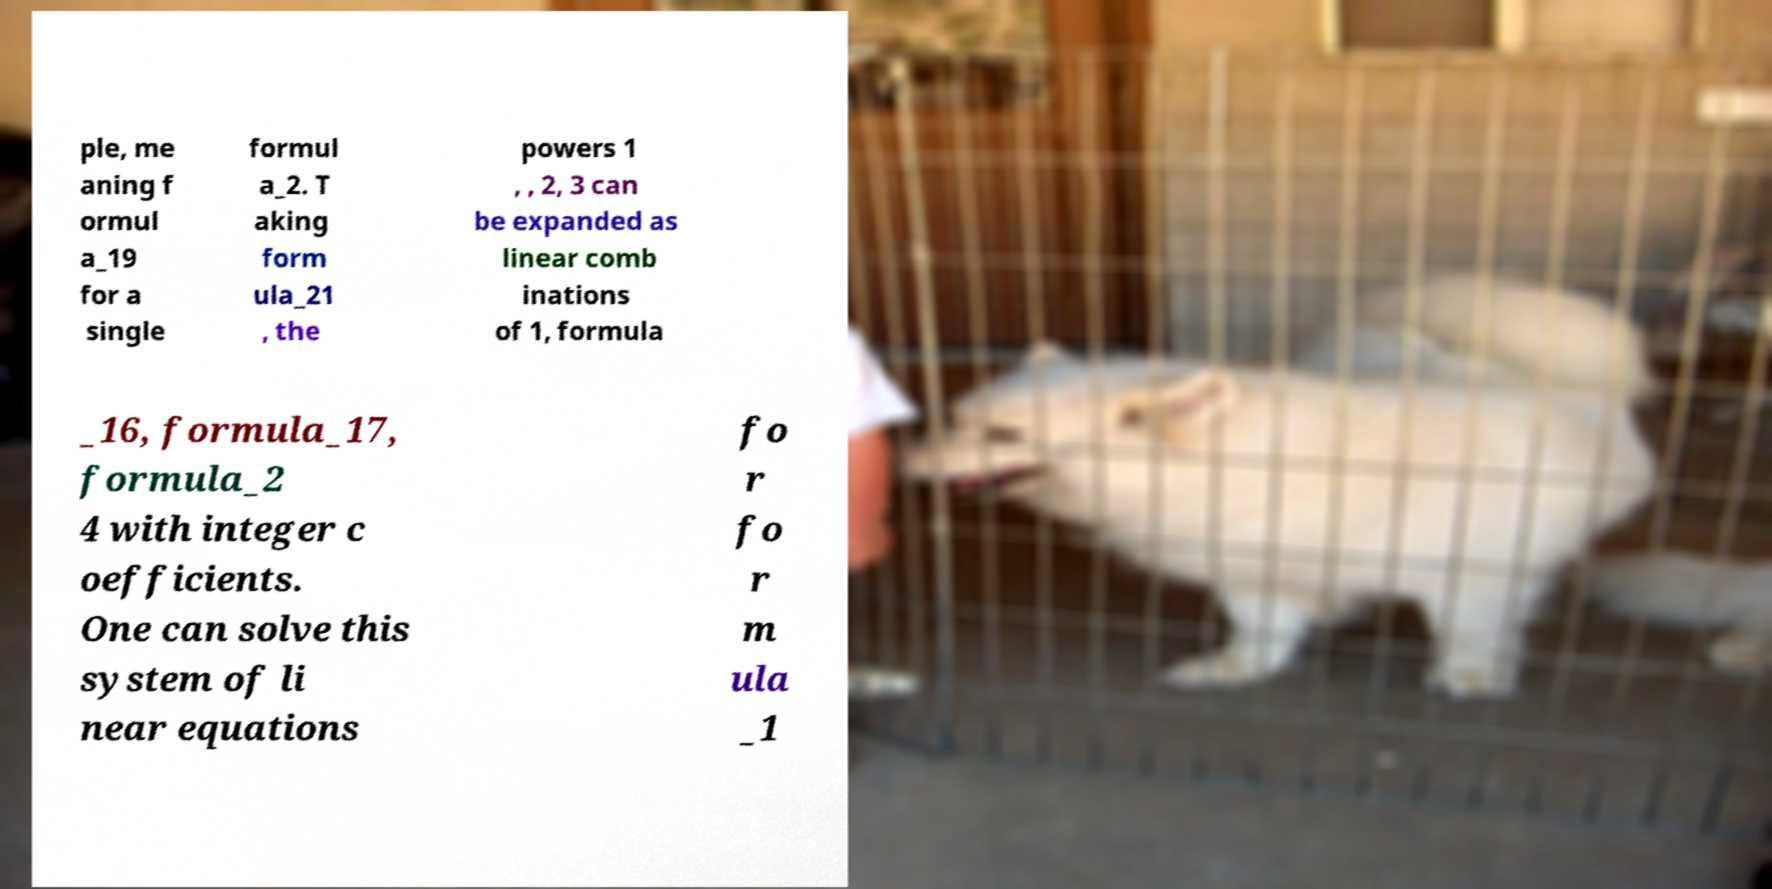Please read and relay the text visible in this image. What does it say? ple, me aning f ormul a_19 for a single formul a_2. T aking form ula_21 , the powers 1 , , 2, 3 can be expanded as linear comb inations of 1, formula _16, formula_17, formula_2 4 with integer c oefficients. One can solve this system of li near equations fo r fo r m ula _1 